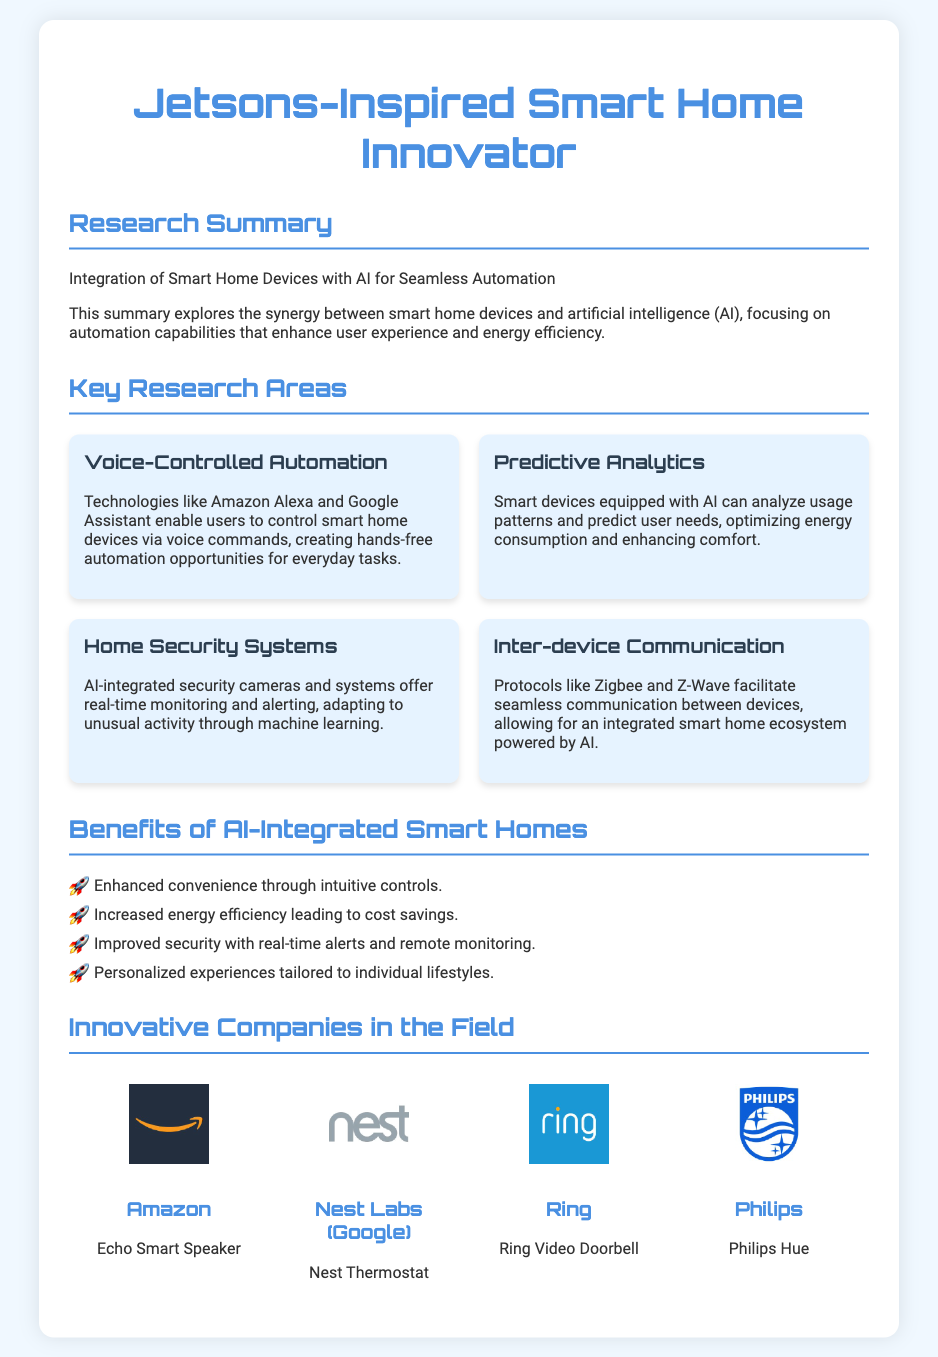What is the title of the research summary? The title provides the main focus of the research, which is "Integration of Smart Home Devices with AI for Seamless Automation."
Answer: Integration of Smart Home Devices with AI for Seamless Automation Which company developed the Echo Smart Speaker? The document names Amazon as the company that created the Echo Smart Speaker.
Answer: Amazon What is one use case mentioned for predictive analytics? Predictive analytics allows smart devices to optimize energy consumption and enhance comfort by analyzing usage patterns.
Answer: Optimizing energy consumption What are the benefits of AI-integrated smart homes listed? The document lists four benefits: enhanced convenience, increased energy efficiency, improved security, and personalized experiences.
Answer: Enhanced convenience, increased energy efficiency, improved security, personalized experiences What technology is used for voice-controlled automation? The document identifies Amazon Alexa and Google Assistant as technologies enabling voice-controlled automation.
Answer: Amazon Alexa and Google Assistant How many innovative companies are mentioned in the document? The document lists four innovative companies in the field of smart home devices integrated with AI.
Answer: Four What type of devices do AI-integrated security systems use? The document specifies that security systems use AI-integrated security cameras for monitoring and alerting.
Answer: Security cameras What does inter-device communication facilitate in smart homes? The document states that inter-device communication enables an integrated smart home ecosystem powered by AI.
Answer: An integrated smart home ecosystem 